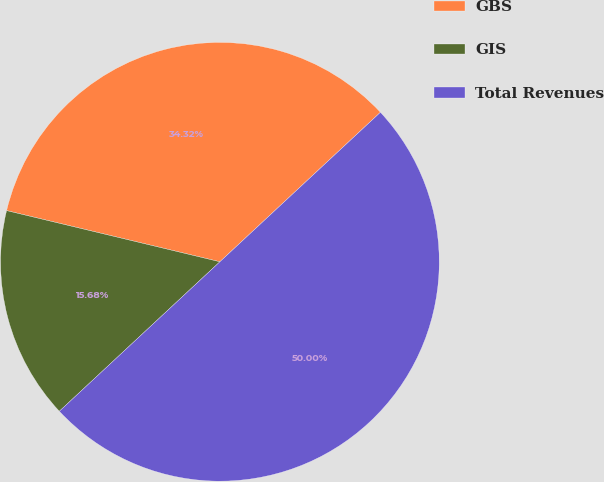<chart> <loc_0><loc_0><loc_500><loc_500><pie_chart><fcel>GBS<fcel>GIS<fcel>Total Revenues<nl><fcel>34.32%<fcel>15.68%<fcel>50.0%<nl></chart> 